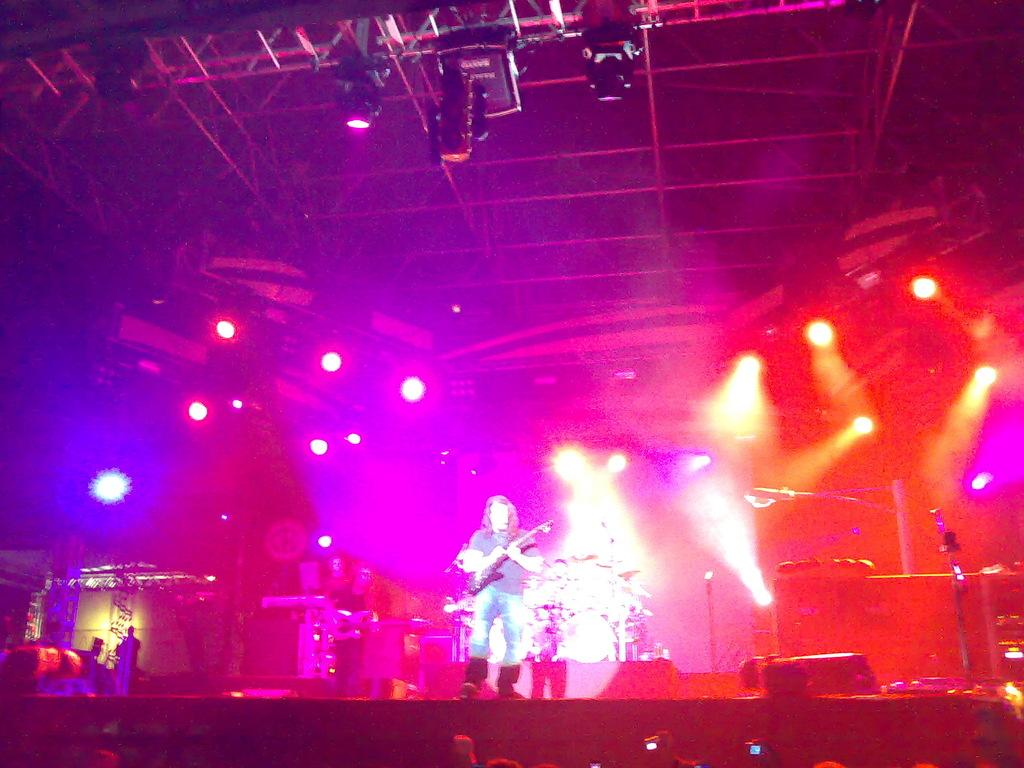What is the main subject of the image? There is a person in the image. What is the person doing in the image? The person is holding a musical instrument. Where is the person standing in the image? The person is standing on the floor. What can be seen at the top of the image? Colorful lights are visible at the top of the image. How much wealth does the person in the image possess? There is no information about the person's wealth in the image. What is the condition of the person's stomach in the image? There is no information about the person's stomach in the image. 